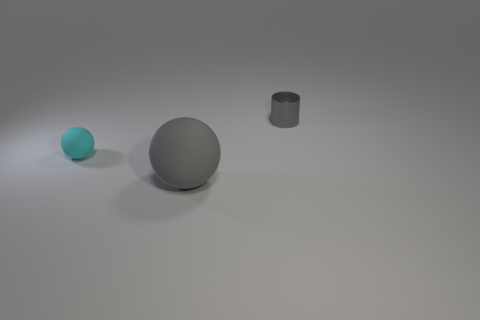What number of gray objects are spheres or metallic cylinders?
Offer a terse response. 2. Is the number of tiny rubber objects left of the large gray thing greater than the number of big red metal spheres?
Offer a terse response. Yes. Are there any small things that have the same color as the big thing?
Your answer should be very brief. Yes. What size is the gray metallic object?
Provide a succinct answer. Small. Does the big rubber thing have the same color as the tiny metallic cylinder?
Your answer should be very brief. Yes. How many objects are either big balls or gray objects to the left of the gray cylinder?
Your answer should be compact. 1. There is a small thing on the right side of the gray object in front of the cylinder; what number of big things are to the left of it?
Keep it short and to the point. 1. There is a small object that is the same color as the big thing; what material is it?
Offer a terse response. Metal. How many big gray objects are there?
Provide a short and direct response. 1. Does the object that is behind the cyan matte thing have the same size as the big gray thing?
Your response must be concise. No. 